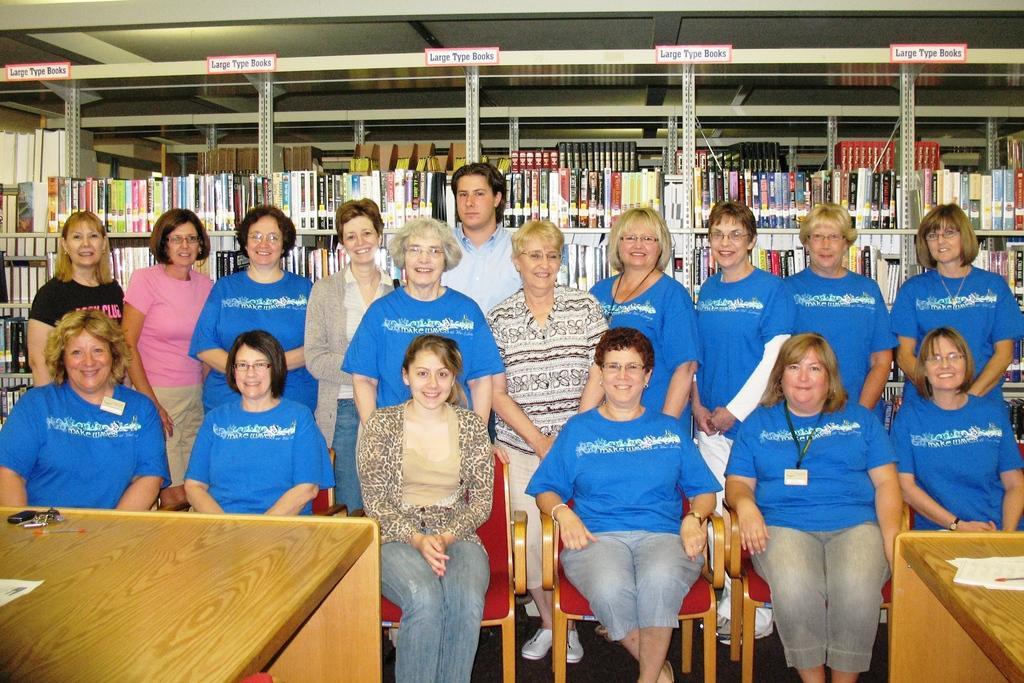In one or two sentences, can you explain what this image depicts? These women all are standing,this woman are sitting on the chair,in the back there is shelf carrying books and in the back there is a man. 